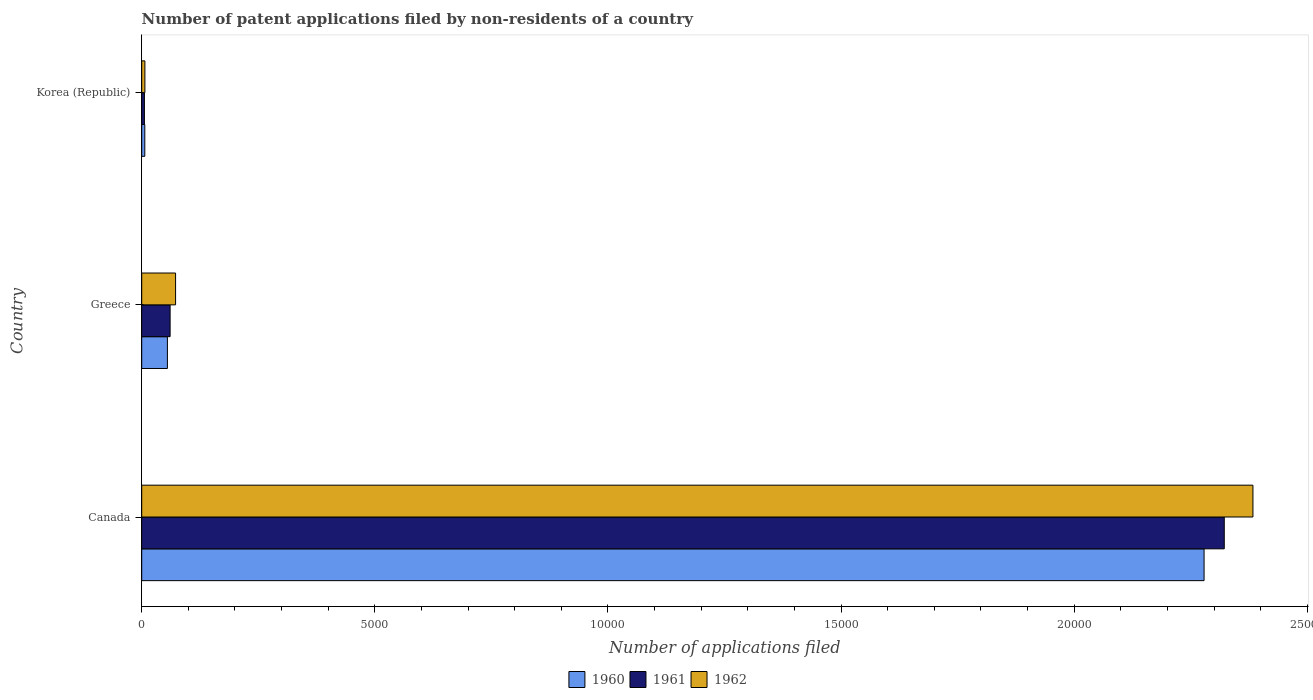How many different coloured bars are there?
Give a very brief answer. 3. Are the number of bars per tick equal to the number of legend labels?
Offer a very short reply. Yes. Are the number of bars on each tick of the Y-axis equal?
Offer a terse response. Yes. How many bars are there on the 3rd tick from the top?
Provide a succinct answer. 3. How many bars are there on the 1st tick from the bottom?
Offer a terse response. 3. What is the label of the 3rd group of bars from the top?
Ensure brevity in your answer.  Canada. In how many cases, is the number of bars for a given country not equal to the number of legend labels?
Make the answer very short. 0. What is the number of applications filed in 1960 in Greece?
Provide a short and direct response. 551. Across all countries, what is the maximum number of applications filed in 1960?
Keep it short and to the point. 2.28e+04. In which country was the number of applications filed in 1960 maximum?
Give a very brief answer. Canada. What is the total number of applications filed in 1961 in the graph?
Ensure brevity in your answer.  2.39e+04. What is the difference between the number of applications filed in 1961 in Greece and that in Korea (Republic)?
Provide a short and direct response. 551. What is the difference between the number of applications filed in 1960 in Greece and the number of applications filed in 1961 in Korea (Republic)?
Ensure brevity in your answer.  493. What is the average number of applications filed in 1962 per country?
Make the answer very short. 8209.33. What is the difference between the number of applications filed in 1960 and number of applications filed in 1962 in Greece?
Offer a terse response. -175. What is the ratio of the number of applications filed in 1960 in Canada to that in Korea (Republic)?
Ensure brevity in your answer.  345.24. Is the difference between the number of applications filed in 1960 in Canada and Korea (Republic) greater than the difference between the number of applications filed in 1962 in Canada and Korea (Republic)?
Your answer should be compact. No. What is the difference between the highest and the second highest number of applications filed in 1961?
Ensure brevity in your answer.  2.26e+04. What is the difference between the highest and the lowest number of applications filed in 1961?
Make the answer very short. 2.32e+04. What does the 2nd bar from the top in Korea (Republic) represents?
Your answer should be very brief. 1961. How many bars are there?
Your answer should be very brief. 9. How many countries are there in the graph?
Make the answer very short. 3. What is the difference between two consecutive major ticks on the X-axis?
Make the answer very short. 5000. Does the graph contain any zero values?
Provide a succinct answer. No. Where does the legend appear in the graph?
Give a very brief answer. Bottom center. How are the legend labels stacked?
Give a very brief answer. Horizontal. What is the title of the graph?
Give a very brief answer. Number of patent applications filed by non-residents of a country. What is the label or title of the X-axis?
Provide a short and direct response. Number of applications filed. What is the label or title of the Y-axis?
Offer a terse response. Country. What is the Number of applications filed in 1960 in Canada?
Provide a succinct answer. 2.28e+04. What is the Number of applications filed in 1961 in Canada?
Make the answer very short. 2.32e+04. What is the Number of applications filed in 1962 in Canada?
Keep it short and to the point. 2.38e+04. What is the Number of applications filed in 1960 in Greece?
Your answer should be very brief. 551. What is the Number of applications filed of 1961 in Greece?
Offer a very short reply. 609. What is the Number of applications filed of 1962 in Greece?
Offer a terse response. 726. What is the Number of applications filed of 1960 in Korea (Republic)?
Offer a terse response. 66. What is the Number of applications filed of 1961 in Korea (Republic)?
Offer a terse response. 58. What is the Number of applications filed in 1962 in Korea (Republic)?
Your answer should be compact. 68. Across all countries, what is the maximum Number of applications filed of 1960?
Provide a succinct answer. 2.28e+04. Across all countries, what is the maximum Number of applications filed in 1961?
Make the answer very short. 2.32e+04. Across all countries, what is the maximum Number of applications filed of 1962?
Offer a very short reply. 2.38e+04. Across all countries, what is the minimum Number of applications filed of 1961?
Your response must be concise. 58. What is the total Number of applications filed of 1960 in the graph?
Keep it short and to the point. 2.34e+04. What is the total Number of applications filed in 1961 in the graph?
Ensure brevity in your answer.  2.39e+04. What is the total Number of applications filed of 1962 in the graph?
Provide a succinct answer. 2.46e+04. What is the difference between the Number of applications filed in 1960 in Canada and that in Greece?
Ensure brevity in your answer.  2.22e+04. What is the difference between the Number of applications filed of 1961 in Canada and that in Greece?
Provide a short and direct response. 2.26e+04. What is the difference between the Number of applications filed in 1962 in Canada and that in Greece?
Your response must be concise. 2.31e+04. What is the difference between the Number of applications filed in 1960 in Canada and that in Korea (Republic)?
Make the answer very short. 2.27e+04. What is the difference between the Number of applications filed of 1961 in Canada and that in Korea (Republic)?
Make the answer very short. 2.32e+04. What is the difference between the Number of applications filed of 1962 in Canada and that in Korea (Republic)?
Your answer should be compact. 2.38e+04. What is the difference between the Number of applications filed in 1960 in Greece and that in Korea (Republic)?
Offer a terse response. 485. What is the difference between the Number of applications filed of 1961 in Greece and that in Korea (Republic)?
Offer a terse response. 551. What is the difference between the Number of applications filed in 1962 in Greece and that in Korea (Republic)?
Offer a terse response. 658. What is the difference between the Number of applications filed in 1960 in Canada and the Number of applications filed in 1961 in Greece?
Your answer should be compact. 2.22e+04. What is the difference between the Number of applications filed in 1960 in Canada and the Number of applications filed in 1962 in Greece?
Your answer should be compact. 2.21e+04. What is the difference between the Number of applications filed of 1961 in Canada and the Number of applications filed of 1962 in Greece?
Offer a terse response. 2.25e+04. What is the difference between the Number of applications filed in 1960 in Canada and the Number of applications filed in 1961 in Korea (Republic)?
Ensure brevity in your answer.  2.27e+04. What is the difference between the Number of applications filed in 1960 in Canada and the Number of applications filed in 1962 in Korea (Republic)?
Your answer should be compact. 2.27e+04. What is the difference between the Number of applications filed in 1961 in Canada and the Number of applications filed in 1962 in Korea (Republic)?
Keep it short and to the point. 2.32e+04. What is the difference between the Number of applications filed in 1960 in Greece and the Number of applications filed in 1961 in Korea (Republic)?
Provide a short and direct response. 493. What is the difference between the Number of applications filed in 1960 in Greece and the Number of applications filed in 1962 in Korea (Republic)?
Offer a very short reply. 483. What is the difference between the Number of applications filed of 1961 in Greece and the Number of applications filed of 1962 in Korea (Republic)?
Keep it short and to the point. 541. What is the average Number of applications filed in 1960 per country?
Provide a succinct answer. 7801. What is the average Number of applications filed of 1961 per country?
Ensure brevity in your answer.  7962. What is the average Number of applications filed in 1962 per country?
Your answer should be very brief. 8209.33. What is the difference between the Number of applications filed in 1960 and Number of applications filed in 1961 in Canada?
Your answer should be very brief. -433. What is the difference between the Number of applications filed in 1960 and Number of applications filed in 1962 in Canada?
Offer a very short reply. -1048. What is the difference between the Number of applications filed of 1961 and Number of applications filed of 1962 in Canada?
Make the answer very short. -615. What is the difference between the Number of applications filed of 1960 and Number of applications filed of 1961 in Greece?
Provide a short and direct response. -58. What is the difference between the Number of applications filed in 1960 and Number of applications filed in 1962 in Greece?
Provide a short and direct response. -175. What is the difference between the Number of applications filed of 1961 and Number of applications filed of 1962 in Greece?
Your answer should be very brief. -117. What is the difference between the Number of applications filed in 1960 and Number of applications filed in 1961 in Korea (Republic)?
Give a very brief answer. 8. What is the difference between the Number of applications filed in 1961 and Number of applications filed in 1962 in Korea (Republic)?
Your answer should be compact. -10. What is the ratio of the Number of applications filed of 1960 in Canada to that in Greece?
Provide a short and direct response. 41.35. What is the ratio of the Number of applications filed in 1961 in Canada to that in Greece?
Keep it short and to the point. 38.13. What is the ratio of the Number of applications filed in 1962 in Canada to that in Greece?
Offer a very short reply. 32.83. What is the ratio of the Number of applications filed in 1960 in Canada to that in Korea (Republic)?
Offer a very short reply. 345.24. What is the ratio of the Number of applications filed in 1961 in Canada to that in Korea (Republic)?
Give a very brief answer. 400.33. What is the ratio of the Number of applications filed of 1962 in Canada to that in Korea (Republic)?
Keep it short and to the point. 350.5. What is the ratio of the Number of applications filed of 1960 in Greece to that in Korea (Republic)?
Provide a short and direct response. 8.35. What is the ratio of the Number of applications filed of 1962 in Greece to that in Korea (Republic)?
Give a very brief answer. 10.68. What is the difference between the highest and the second highest Number of applications filed of 1960?
Your response must be concise. 2.22e+04. What is the difference between the highest and the second highest Number of applications filed in 1961?
Provide a short and direct response. 2.26e+04. What is the difference between the highest and the second highest Number of applications filed of 1962?
Give a very brief answer. 2.31e+04. What is the difference between the highest and the lowest Number of applications filed in 1960?
Keep it short and to the point. 2.27e+04. What is the difference between the highest and the lowest Number of applications filed of 1961?
Keep it short and to the point. 2.32e+04. What is the difference between the highest and the lowest Number of applications filed of 1962?
Your response must be concise. 2.38e+04. 